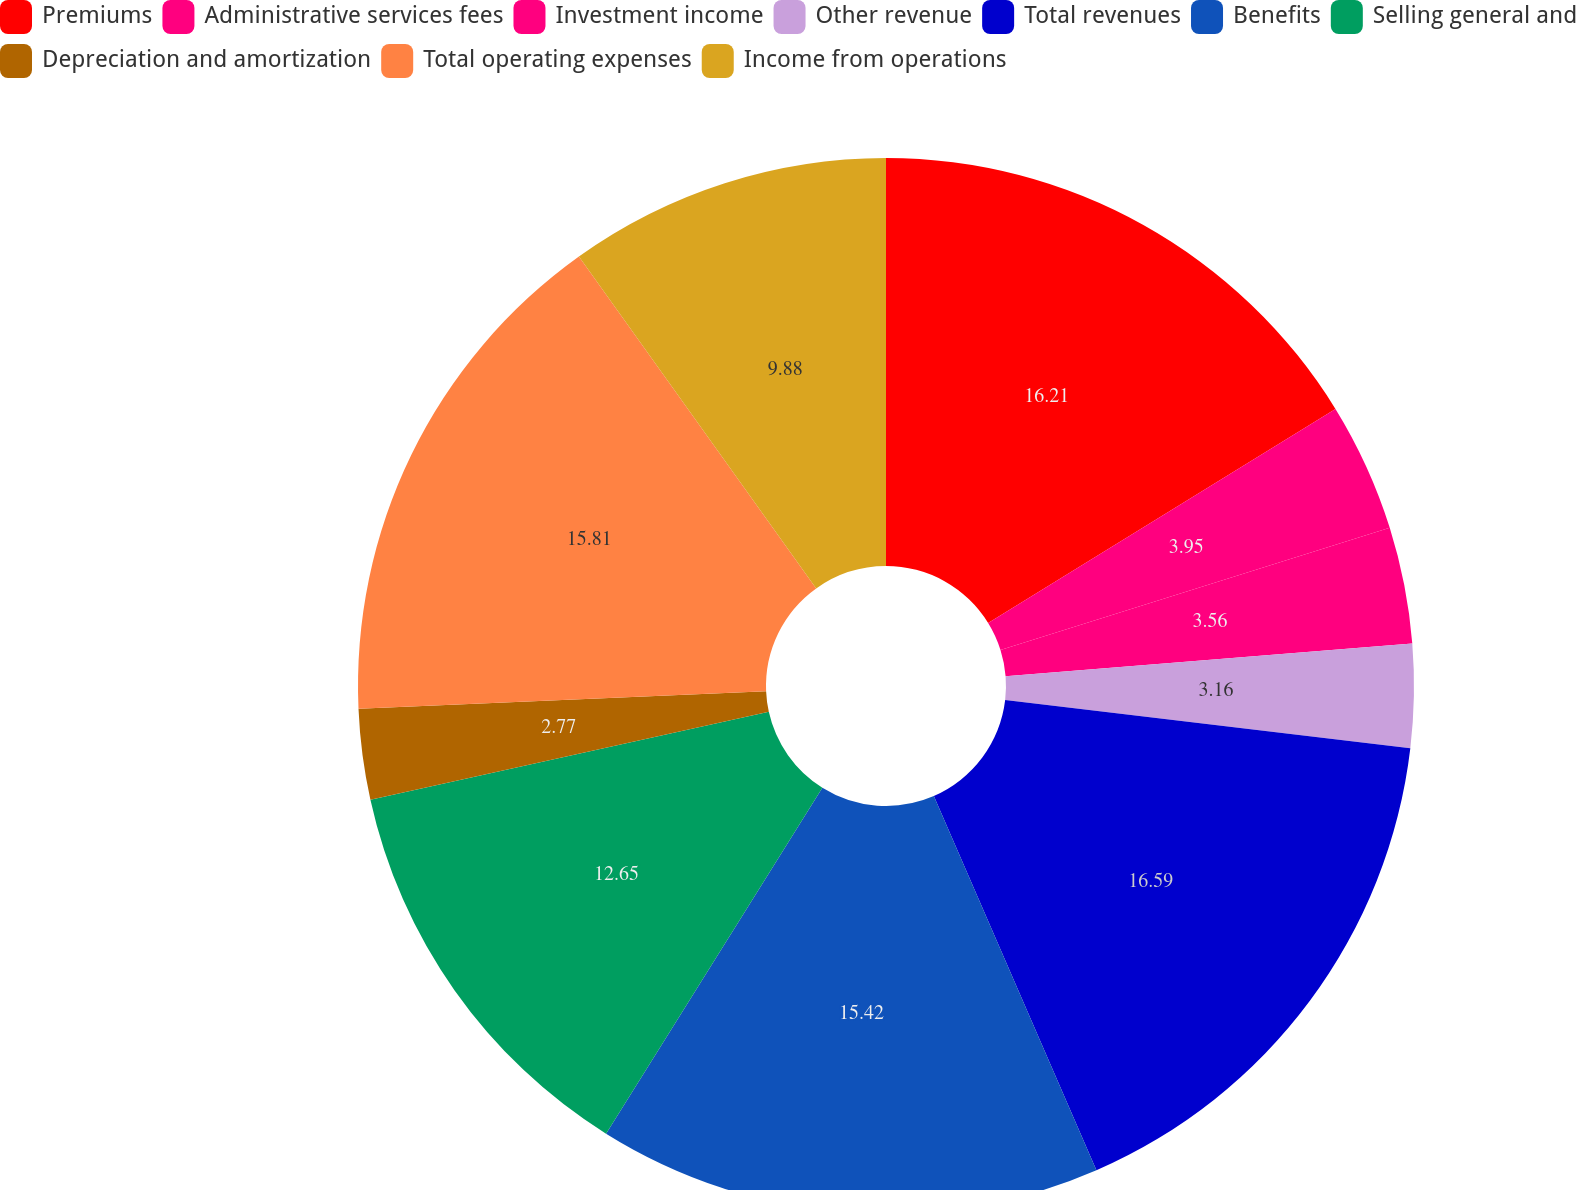Convert chart. <chart><loc_0><loc_0><loc_500><loc_500><pie_chart><fcel>Premiums<fcel>Administrative services fees<fcel>Investment income<fcel>Other revenue<fcel>Total revenues<fcel>Benefits<fcel>Selling general and<fcel>Depreciation and amortization<fcel>Total operating expenses<fcel>Income from operations<nl><fcel>16.21%<fcel>3.95%<fcel>3.56%<fcel>3.16%<fcel>16.6%<fcel>15.42%<fcel>12.65%<fcel>2.77%<fcel>15.81%<fcel>9.88%<nl></chart> 